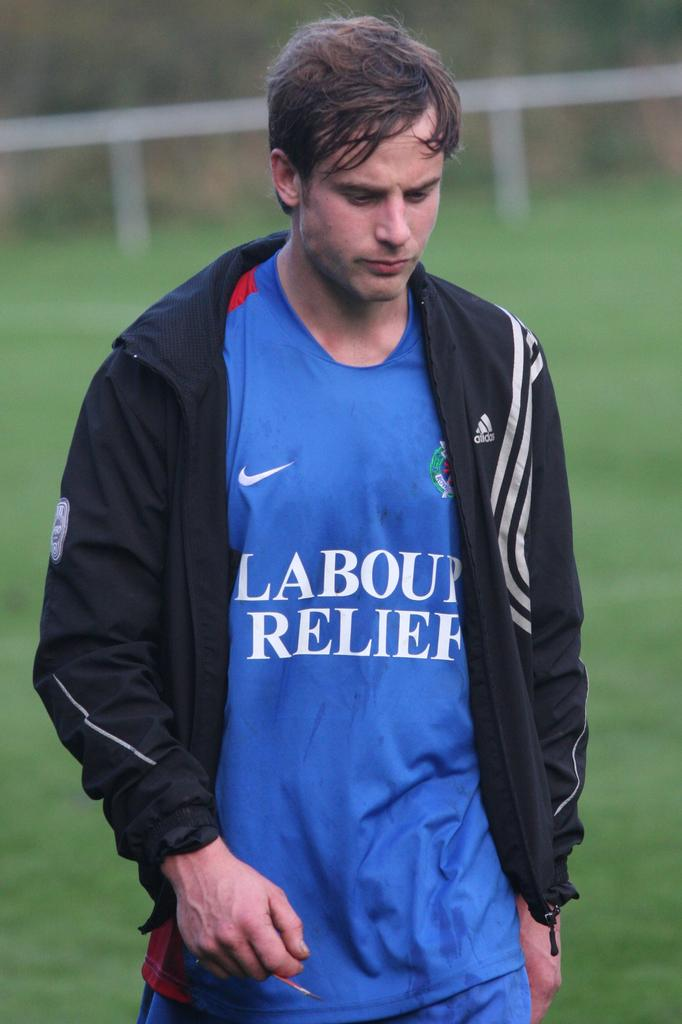<image>
Present a compact description of the photo's key features. A player is wearing a Nike t-shirt that has Labour Relief written on it. 